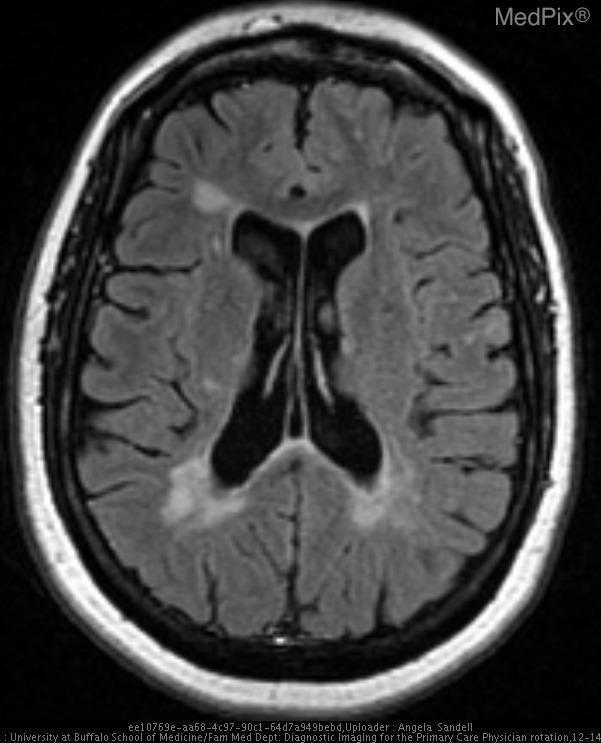What type of contrast agent is used in this mri?
Short answer required. Gadolinium. What would you call the lesions seen?
Answer briefly. Ms plaques. What is the name of the lesions seen in this image?
Quick response, please. Ms plaques. The pathology seen in this image is typical of what disease?
Concise answer only. Multiple sclerosis. What disease does the pathology suggest?
Concise answer only. Multiple sclerosis. In what parts of the brain are the lesions located?
Answer briefly. Cerebrum and lateral ventricles. Where do you see the lesions?
Write a very short answer. Cerebrum and lateral ventricles. 